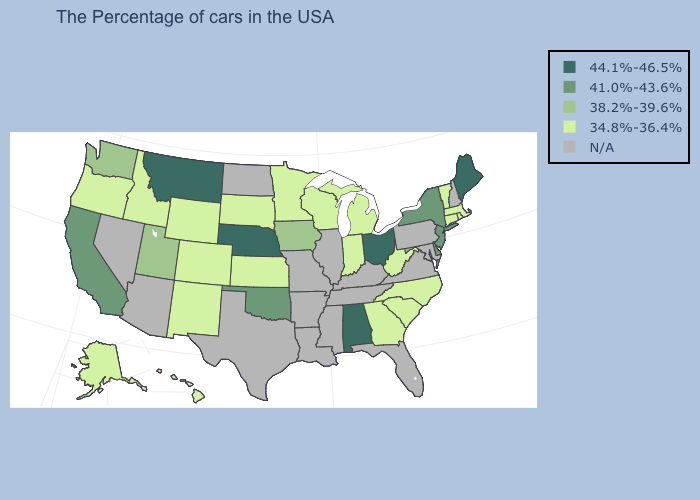Does the map have missing data?
Keep it brief. Yes. What is the value of Nebraska?
Quick response, please. 44.1%-46.5%. How many symbols are there in the legend?
Concise answer only. 5. What is the value of Georgia?
Quick response, please. 34.8%-36.4%. Does New Mexico have the lowest value in the USA?
Answer briefly. Yes. What is the highest value in states that border Colorado?
Quick response, please. 44.1%-46.5%. What is the lowest value in the USA?
Answer briefly. 34.8%-36.4%. What is the value of Pennsylvania?
Concise answer only. N/A. Which states hav the highest value in the South?
Concise answer only. Alabama. Does the first symbol in the legend represent the smallest category?
Be succinct. No. Is the legend a continuous bar?
Give a very brief answer. No. What is the value of Mississippi?
Give a very brief answer. N/A. What is the lowest value in the USA?
Keep it brief. 34.8%-36.4%. Which states have the highest value in the USA?
Be succinct. Maine, Ohio, Alabama, Nebraska, Montana. 